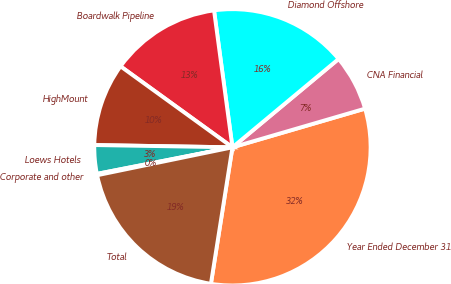Convert chart. <chart><loc_0><loc_0><loc_500><loc_500><pie_chart><fcel>Year Ended December 31<fcel>CNA Financial<fcel>Diamond Offshore<fcel>Boardwalk Pipeline<fcel>HighMount<fcel>Loews Hotels<fcel>Corporate and other<fcel>Total<nl><fcel>32.01%<fcel>6.53%<fcel>16.08%<fcel>12.9%<fcel>9.71%<fcel>3.34%<fcel>0.16%<fcel>19.27%<nl></chart> 